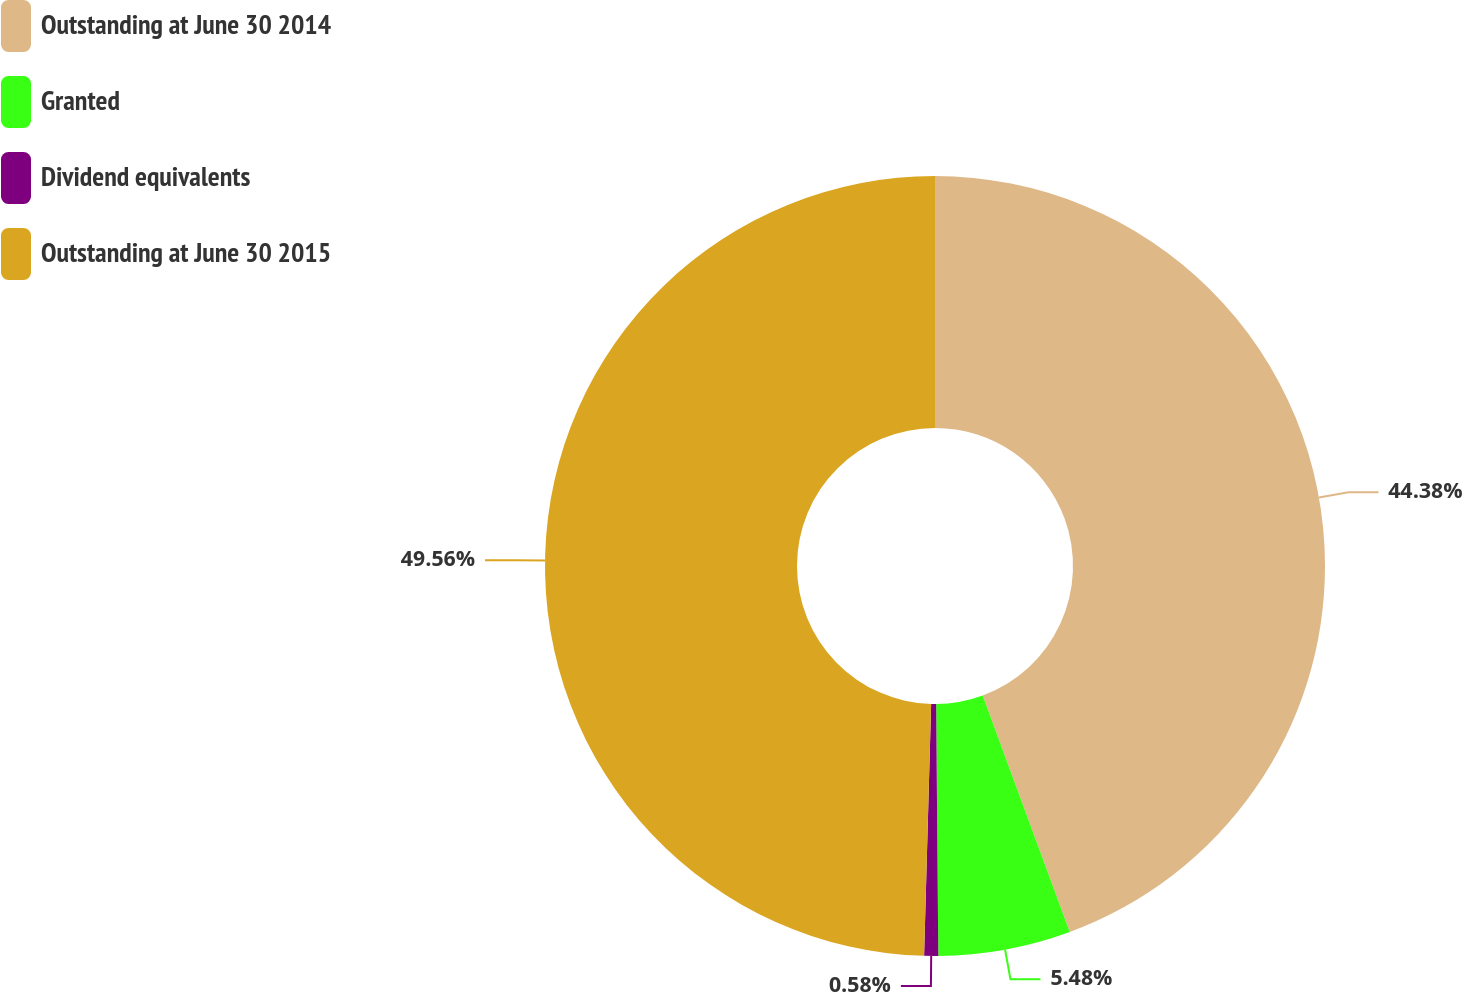<chart> <loc_0><loc_0><loc_500><loc_500><pie_chart><fcel>Outstanding at June 30 2014<fcel>Granted<fcel>Dividend equivalents<fcel>Outstanding at June 30 2015<nl><fcel>44.38%<fcel>5.48%<fcel>0.58%<fcel>49.55%<nl></chart> 